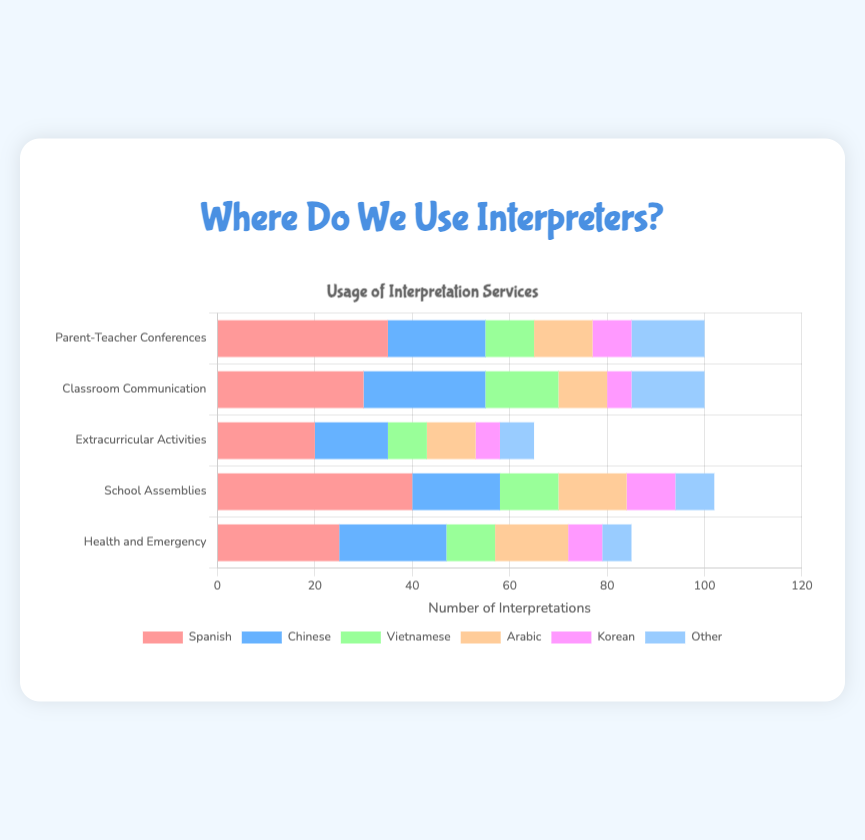Which situation uses interpreters for Spanish the most? Look at each bar for Spanish and find the one with the largest length. "School Assemblies" has the highest value of 40.
Answer: School Assemblies Which language is used the least for interpretation in Parent-Teacher Conferences? Check all the bars for "Parent-Teacher Conferences," and look for the smallest one. Korean with 8 is the least.
Answer: Korean What is the total number of interpretations for Arabic across all situations? Sum the values for Arabic in all situations: 12 (Parent-Teacher Conferences) + 10 (Classroom Communication) + 10 (Extracurricular Activities) + 14 (School Assemblies) + 15 (Health and Emergency). The total is 61.
Answer: 61 Which situation has an equal number of interpretations for Spanish and Other languages? Examine the bars for each situation, focusing on Spanish and Other bars. In "Classroom Communication," both Spanish and Other are 15.
Answer: Classroom Communication What is the difference between the number of interpretations for Spanish in Health and Emergency versus Parent-Teacher Conferences? Subtract Spanish interpretations in Health and Emergency (25) from Parent-Teacher Conferences (35). The difference is 35 - 25 = 10.
Answer: 10 How many more interpretations are provided in Vietnamese for Classroom Communication compared to Extracurricular Activities? Subtract the Vietnamese interpretations in Extracurricular Activities (8) from Classroom Communication (15). The difference is 15 - 8 = 7.
Answer: 7 Which situation combines to offer the highest number of interpretations? Add the usage data for each situation and find the highest total: Parent-Teacher Conferences (100), Classroom Communication (100), Extracurricular Activities (65), School Assemblies (102), Health and Emergency (85). "School Assemblies" has the highest total of 102.
Answer: School Assemblies Among all the situations, which language is used third most overall? Sum up usage data for each language and determine the third highest total: Spanish (150), Chinese (100), Vietnamese (55), Arabic (61), Korean (35), Other (51). The third highest is Vietnamese with 55.
Answer: Vietnamese Which two situations have the same number of total interpretations? Calculate the total for each situation and compare. Both Parent-Teacher Conferences and Classroom Communication have a total of 100.
Answer: Parent-Teacher Conferences and Classroom Communication What are the combined interpretations for Korean in Classroom Communication and Health and Emergency? Add the values of Korean in Classroom Communication (5) and Health and Emergency (7). The total is 5 + 7 = 12.
Answer: 12 